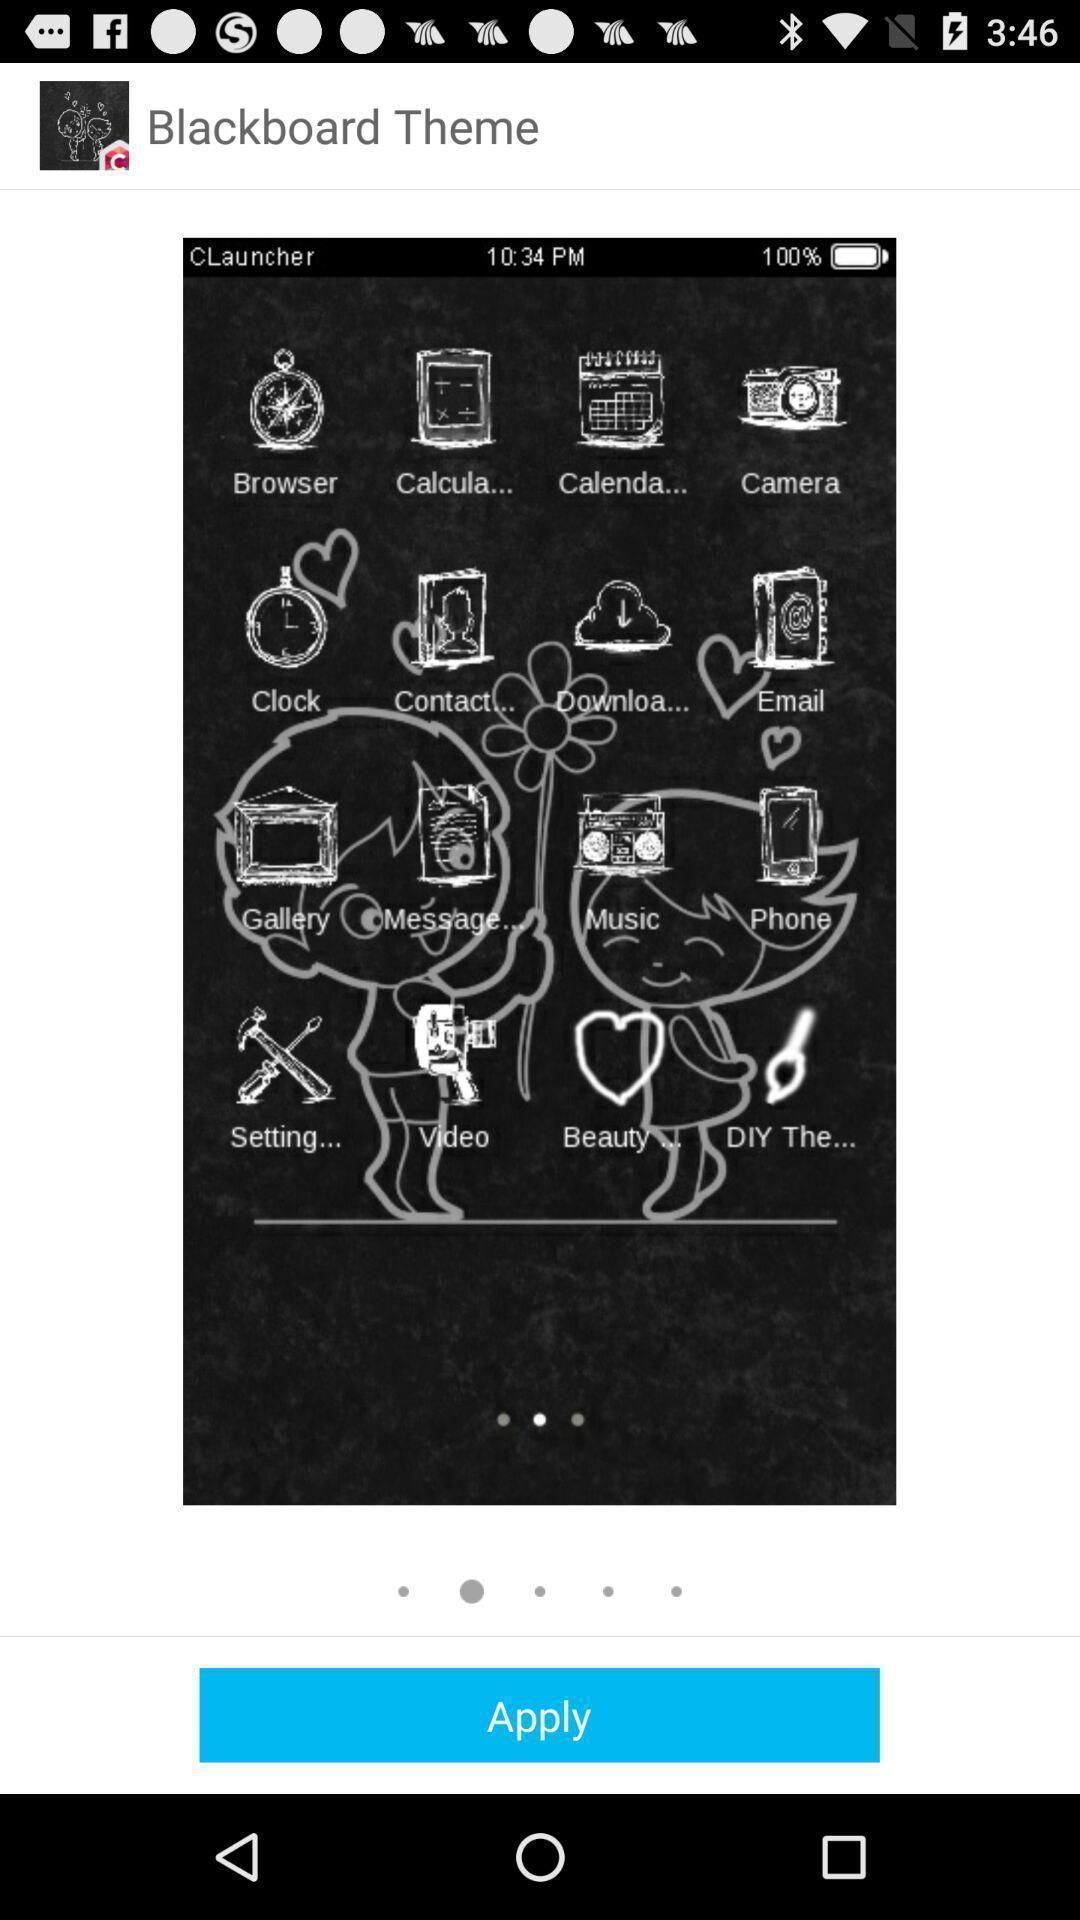Tell me about the visual elements in this screen capture. Welcome screen showing blackboard theme. 